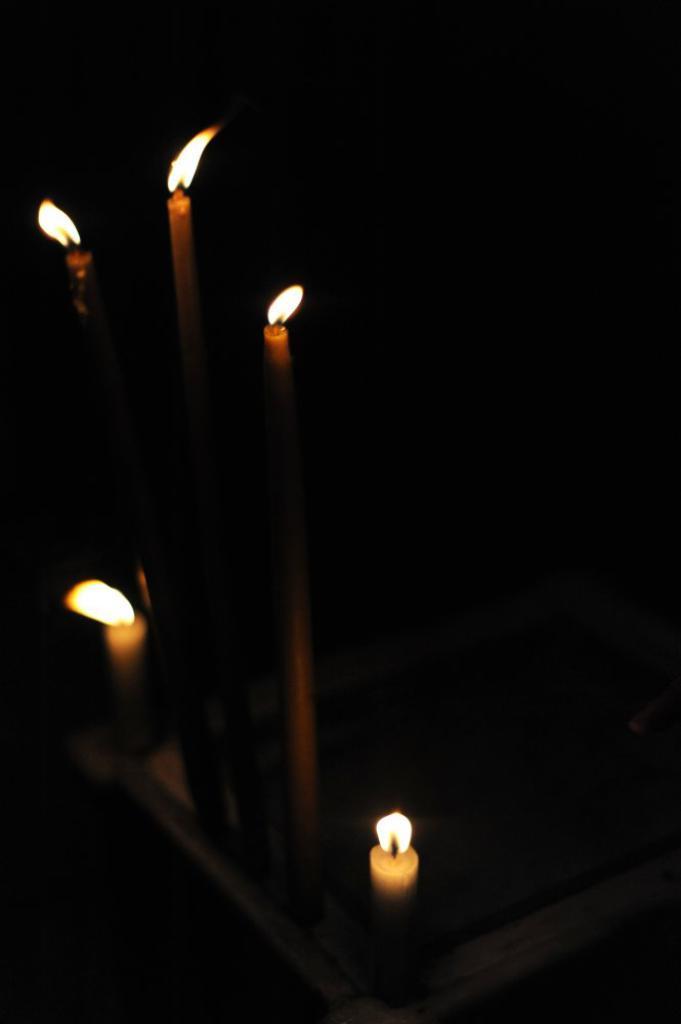How would you summarize this image in a sentence or two? In this image I can see few candles in the dark. 